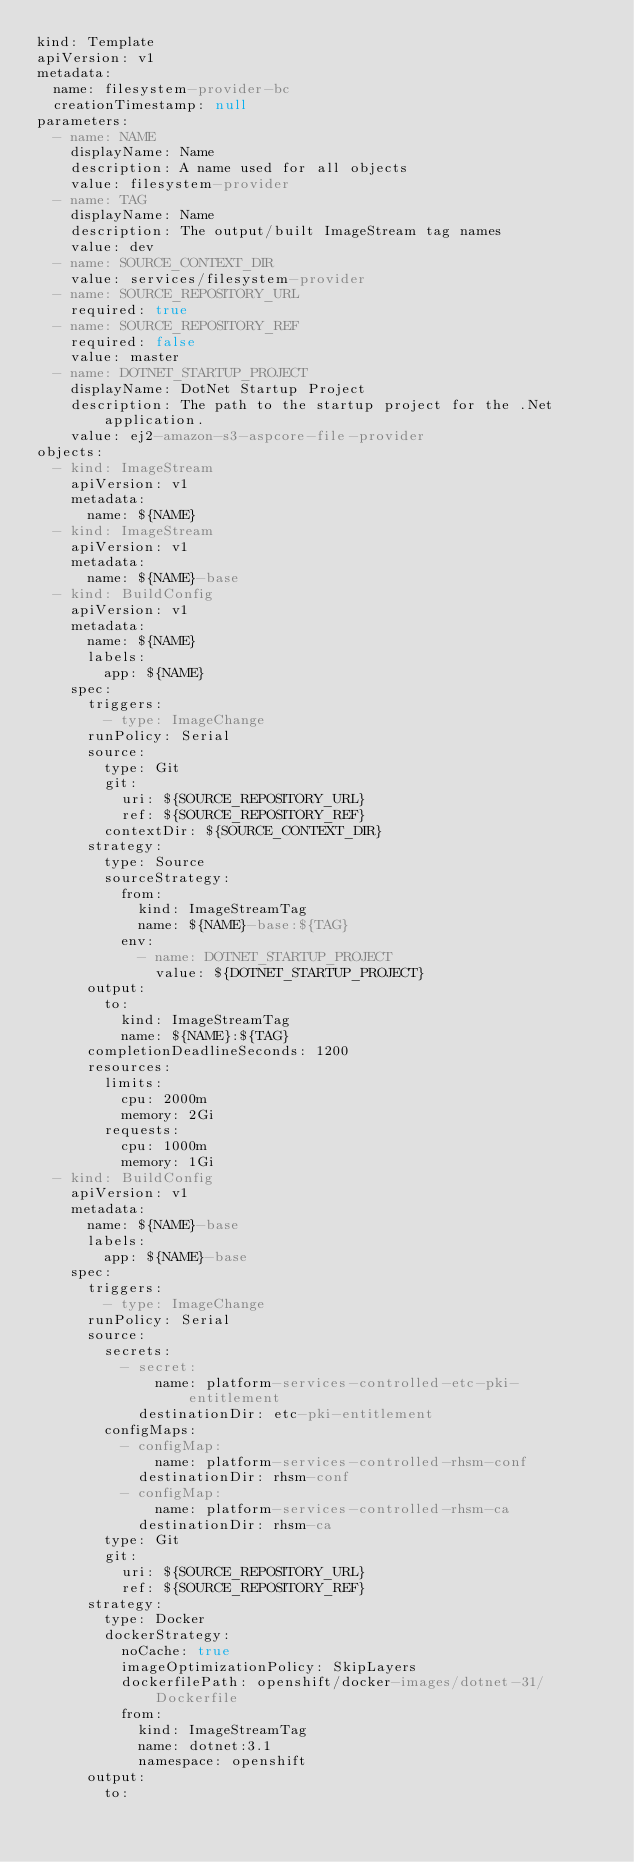Convert code to text. <code><loc_0><loc_0><loc_500><loc_500><_YAML_>kind: Template
apiVersion: v1
metadata:
  name: filesystem-provider-bc
  creationTimestamp: null
parameters:
  - name: NAME
    displayName: Name
    description: A name used for all objects
    value: filesystem-provider
  - name: TAG
    displayName: Name
    description: The output/built ImageStream tag names
    value: dev
  - name: SOURCE_CONTEXT_DIR
    value: services/filesystem-provider
  - name: SOURCE_REPOSITORY_URL
    required: true
  - name: SOURCE_REPOSITORY_REF
    required: false
    value: master
  - name: DOTNET_STARTUP_PROJECT
    displayName: DotNet Startup Project
    description: The path to the startup project for the .Net application.
    value: ej2-amazon-s3-aspcore-file-provider
objects:
  - kind: ImageStream
    apiVersion: v1
    metadata:
      name: ${NAME}
  - kind: ImageStream
    apiVersion: v1
    metadata:
      name: ${NAME}-base
  - kind: BuildConfig
    apiVersion: v1
    metadata:
      name: ${NAME}
      labels:
        app: ${NAME}
    spec:
      triggers:
        - type: ImageChange
      runPolicy: Serial
      source:
        type: Git
        git:
          uri: ${SOURCE_REPOSITORY_URL}
          ref: ${SOURCE_REPOSITORY_REF}
        contextDir: ${SOURCE_CONTEXT_DIR}
      strategy:
        type: Source
        sourceStrategy:
          from:
            kind: ImageStreamTag
            name: ${NAME}-base:${TAG}
          env:
            - name: DOTNET_STARTUP_PROJECT
              value: ${DOTNET_STARTUP_PROJECT}
      output:
        to:
          kind: ImageStreamTag
          name: ${NAME}:${TAG}
      completionDeadlineSeconds: 1200
      resources:
        limits:
          cpu: 2000m
          memory: 2Gi
        requests:
          cpu: 1000m
          memory: 1Gi
  - kind: BuildConfig
    apiVersion: v1
    metadata:
      name: ${NAME}-base
      labels:
        app: ${NAME}-base
    spec:
      triggers:
        - type: ImageChange
      runPolicy: Serial
      source:
        secrets:
          - secret:
              name: platform-services-controlled-etc-pki-entitlement
            destinationDir: etc-pki-entitlement
        configMaps:
          - configMap:
              name: platform-services-controlled-rhsm-conf
            destinationDir: rhsm-conf
          - configMap:
              name: platform-services-controlled-rhsm-ca
            destinationDir: rhsm-ca
        type: Git
        git:
          uri: ${SOURCE_REPOSITORY_URL}
          ref: ${SOURCE_REPOSITORY_REF}
      strategy:
        type: Docker
        dockerStrategy:
          noCache: true
          imageOptimizationPolicy: SkipLayers
          dockerfilePath: openshift/docker-images/dotnet-31/Dockerfile
          from:
            kind: ImageStreamTag
            name: dotnet:3.1
            namespace: openshift
      output:
        to:</code> 